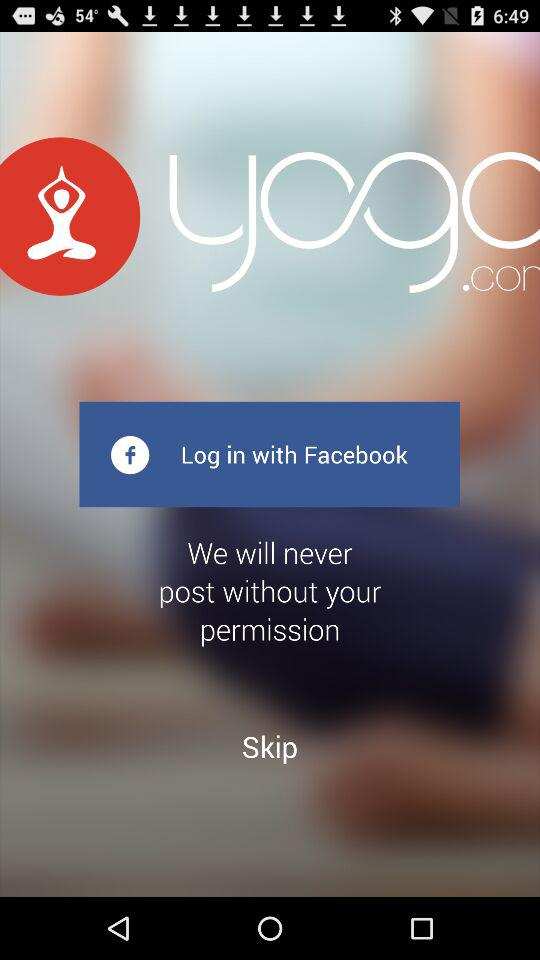How much does the application cost?
When the provided information is insufficient, respond with <no answer>. <no answer> 